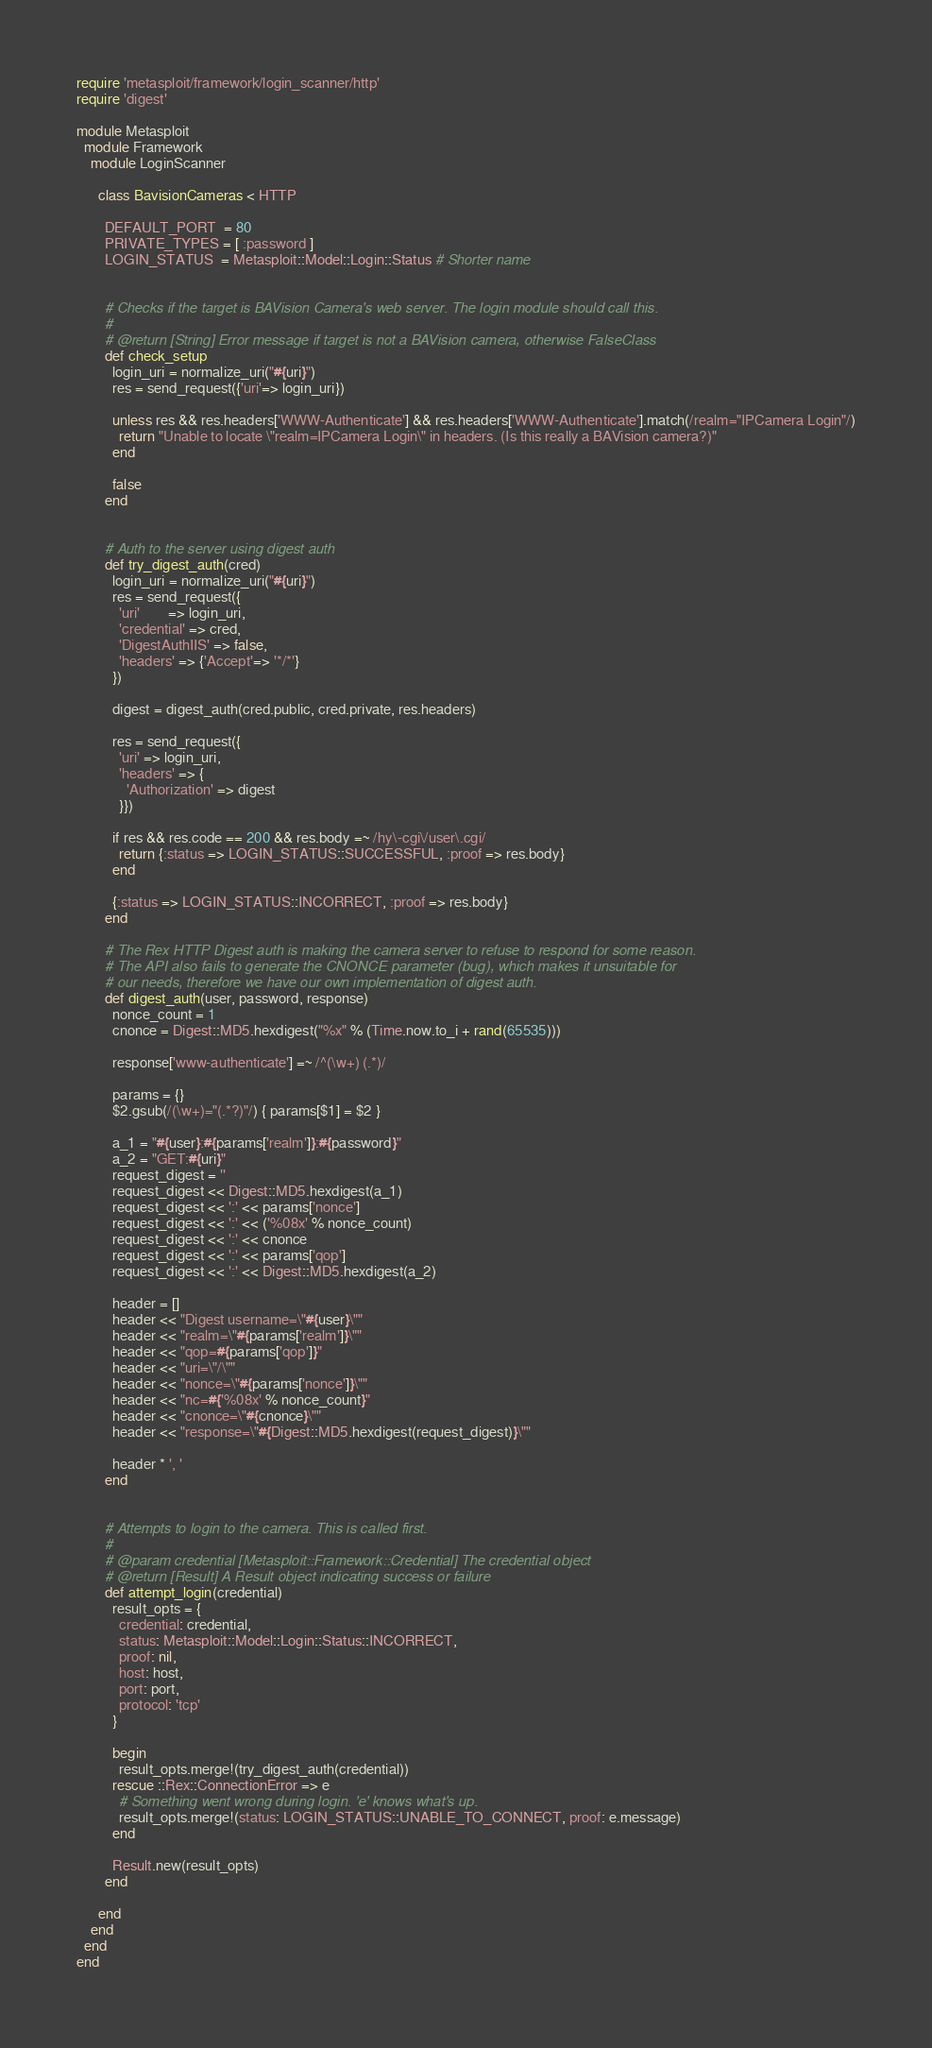<code> <loc_0><loc_0><loc_500><loc_500><_Ruby_>require 'metasploit/framework/login_scanner/http'
require 'digest'

module Metasploit
  module Framework
    module LoginScanner

      class BavisionCameras < HTTP

        DEFAULT_PORT  = 80
        PRIVATE_TYPES = [ :password ]
        LOGIN_STATUS  = Metasploit::Model::Login::Status # Shorter name


        # Checks if the target is BAVision Camera's web server. The login module should call this.
        #
        # @return [String] Error message if target is not a BAVision camera, otherwise FalseClass
        def check_setup
          login_uri = normalize_uri("#{uri}")
          res = send_request({'uri'=> login_uri})

          unless res && res.headers['WWW-Authenticate'] && res.headers['WWW-Authenticate'].match(/realm="IPCamera Login"/)
            return "Unable to locate \"realm=IPCamera Login\" in headers. (Is this really a BAVision camera?)"
          end

          false
        end


        # Auth to the server using digest auth
        def try_digest_auth(cred)
          login_uri = normalize_uri("#{uri}")
          res = send_request({
            'uri'        => login_uri,
            'credential' => cred,
            'DigestAuthIIS' => false,
            'headers' => {'Accept'=> '*/*'}
          })

          digest = digest_auth(cred.public, cred.private, res.headers)

          res = send_request({
            'uri' => login_uri,
            'headers' => {
              'Authorization' => digest
            }})

          if res && res.code == 200 && res.body =~ /hy\-cgi\/user\.cgi/
            return {:status => LOGIN_STATUS::SUCCESSFUL, :proof => res.body}
          end

          {:status => LOGIN_STATUS::INCORRECT, :proof => res.body}
        end

        # The Rex HTTP Digest auth is making the camera server to refuse to respond for some reason.
        # The API also fails to generate the CNONCE parameter (bug), which makes it unsuitable for
        # our needs, therefore we have our own implementation of digest auth.
        def digest_auth(user, password, response)
          nonce_count = 1
          cnonce = Digest::MD5.hexdigest("%x" % (Time.now.to_i + rand(65535)))

          response['www-authenticate'] =~ /^(\w+) (.*)/

          params = {}
          $2.gsub(/(\w+)="(.*?)"/) { params[$1] = $2 }

          a_1 = "#{user}:#{params['realm']}:#{password}"
          a_2 = "GET:#{uri}"
          request_digest = ''
          request_digest << Digest::MD5.hexdigest(a_1)
          request_digest << ':' << params['nonce']
          request_digest << ':' << ('%08x' % nonce_count)
          request_digest << ':' << cnonce
          request_digest << ':' << params['qop']
          request_digest << ':' << Digest::MD5.hexdigest(a_2)

          header = []
          header << "Digest username=\"#{user}\""
          header << "realm=\"#{params['realm']}\""
          header << "qop=#{params['qop']}"
          header << "uri=\"/\""
          header << "nonce=\"#{params['nonce']}\""
          header << "nc=#{'%08x' % nonce_count}"
          header << "cnonce=\"#{cnonce}\""
          header << "response=\"#{Digest::MD5.hexdigest(request_digest)}\""

          header * ', '
        end


        # Attempts to login to the camera. This is called first.
        #
        # @param credential [Metasploit::Framework::Credential] The credential object
        # @return [Result] A Result object indicating success or failure
        def attempt_login(credential)
          result_opts = {
            credential: credential,
            status: Metasploit::Model::Login::Status::INCORRECT,
            proof: nil,
            host: host,
            port: port,
            protocol: 'tcp'
          }

          begin
            result_opts.merge!(try_digest_auth(credential))
          rescue ::Rex::ConnectionError => e
            # Something went wrong during login. 'e' knows what's up.
            result_opts.merge!(status: LOGIN_STATUS::UNABLE_TO_CONNECT, proof: e.message)
          end

          Result.new(result_opts)
        end

      end
    end
  end
end

</code> 